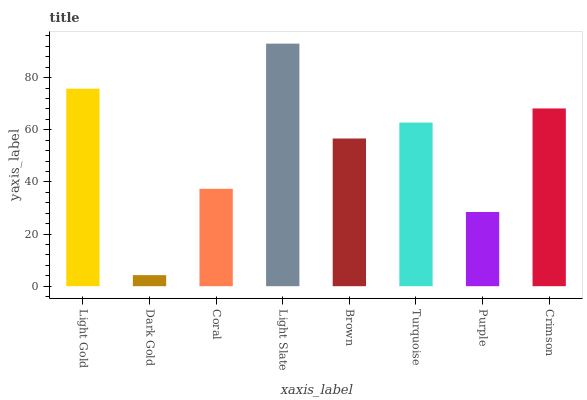Is Dark Gold the minimum?
Answer yes or no. Yes. Is Light Slate the maximum?
Answer yes or no. Yes. Is Coral the minimum?
Answer yes or no. No. Is Coral the maximum?
Answer yes or no. No. Is Coral greater than Dark Gold?
Answer yes or no. Yes. Is Dark Gold less than Coral?
Answer yes or no. Yes. Is Dark Gold greater than Coral?
Answer yes or no. No. Is Coral less than Dark Gold?
Answer yes or no. No. Is Turquoise the high median?
Answer yes or no. Yes. Is Brown the low median?
Answer yes or no. Yes. Is Brown the high median?
Answer yes or no. No. Is Dark Gold the low median?
Answer yes or no. No. 